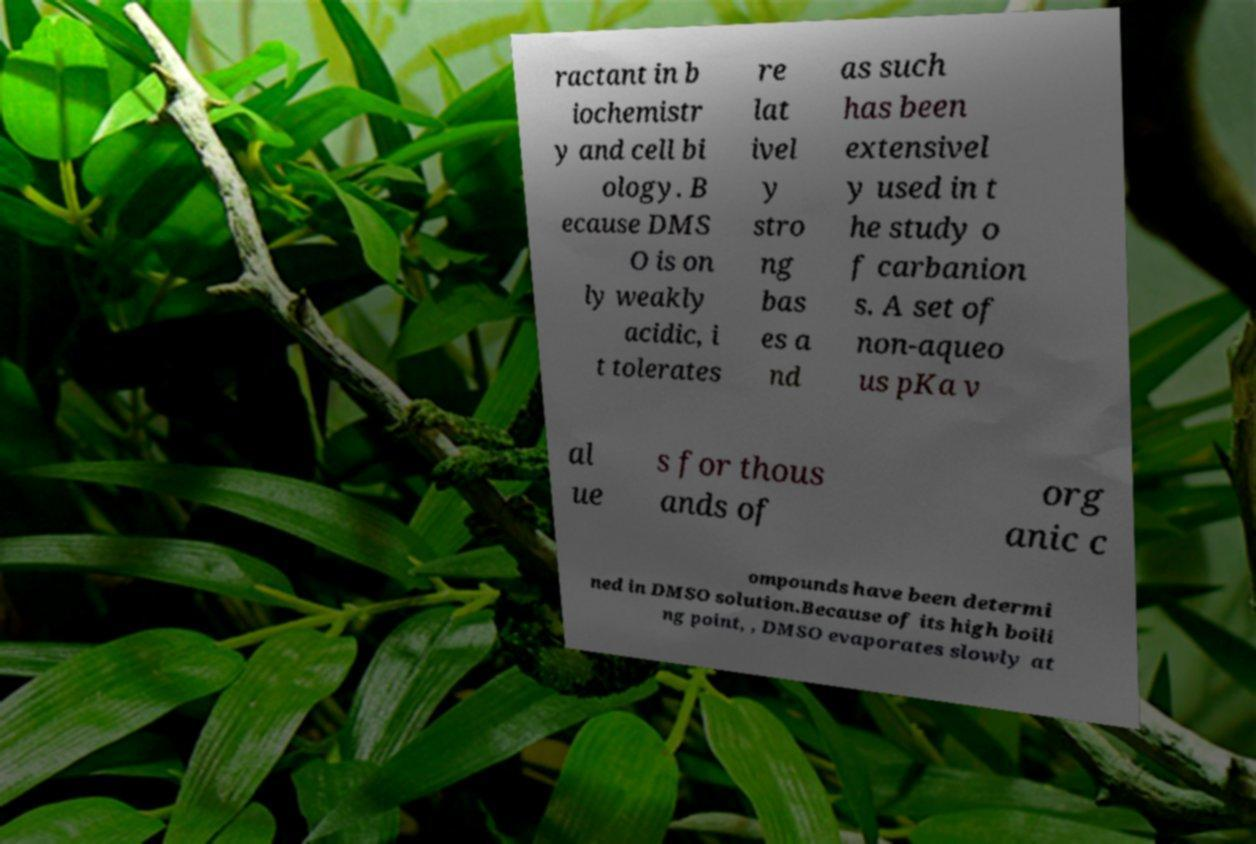Please identify and transcribe the text found in this image. ractant in b iochemistr y and cell bi ology. B ecause DMS O is on ly weakly acidic, i t tolerates re lat ivel y stro ng bas es a nd as such has been extensivel y used in t he study o f carbanion s. A set of non-aqueo us pKa v al ue s for thous ands of org anic c ompounds have been determi ned in DMSO solution.Because of its high boili ng point, , DMSO evaporates slowly at 